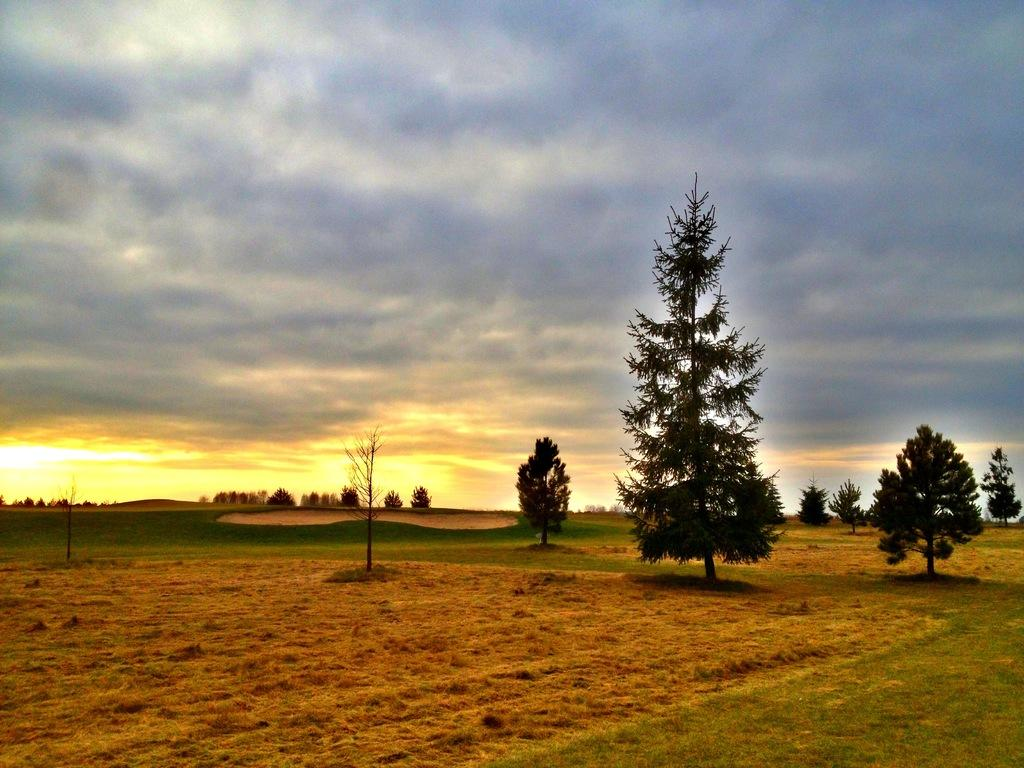What type of living organisms can be seen in the image? Plants and grass are visible in the image. What time of day is depicted in the image? The image depicts a sunrise. What can be seen in the sky in the image? There are clouds in the sky in the image. How many chairs are visible in the image? There are no chairs present in the image. What type of vegetable can be seen growing among the plants in the image? There is no vegetable visible in the image; only plants and grass are present. 